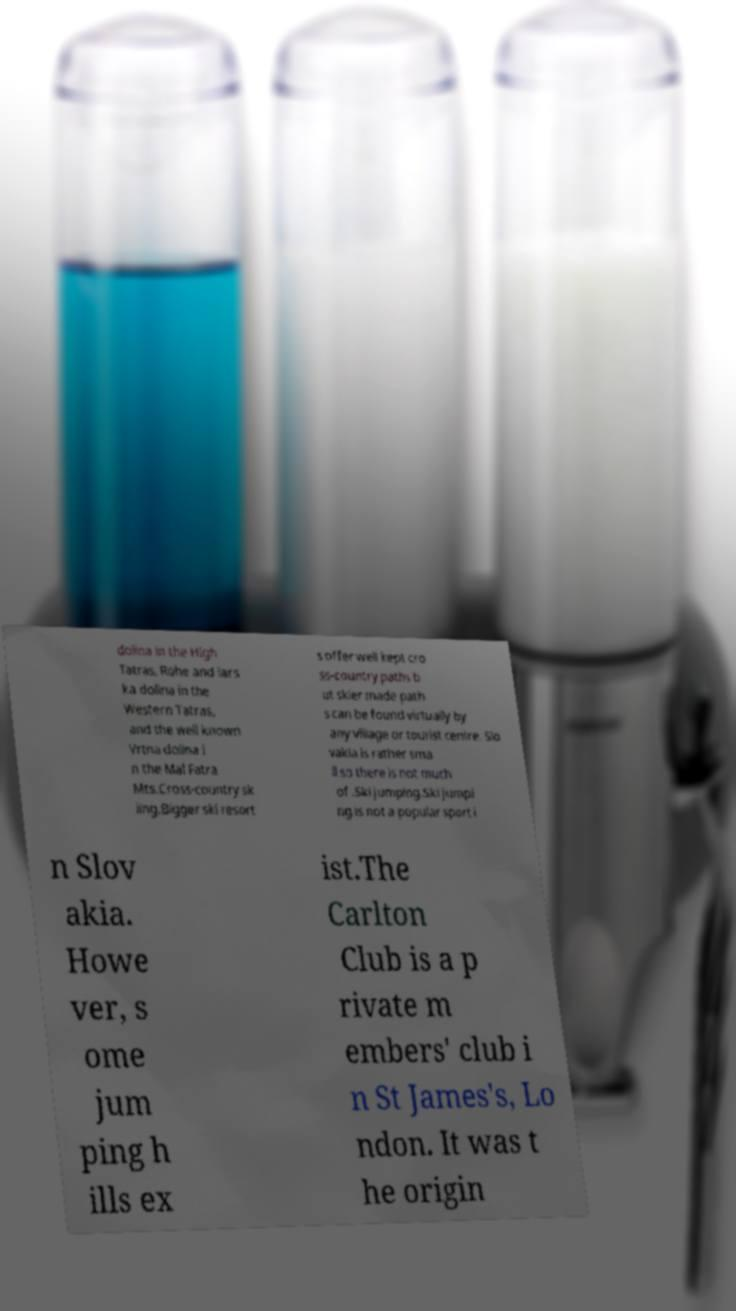What messages or text are displayed in this image? I need them in a readable, typed format. dolina in the High Tatras, Rohe and iars ka dolina in the Western Tatras, and the well known Vrtna dolina i n the Mal Fatra Mts.Cross-country sk iing.Bigger ski resort s offer well kept cro ss-country paths b ut skier made path s can be found virtually by any village or tourist centre. Slo vakia is rather sma ll so there is not much of .Ski jumping.Ski jumpi ng is not a popular sport i n Slov akia. Howe ver, s ome jum ping h ills ex ist.The Carlton Club is a p rivate m embers' club i n St James's, Lo ndon. It was t he origin 